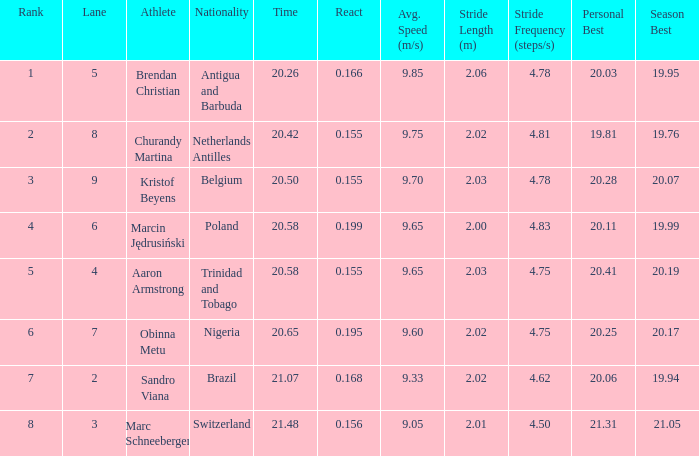How much Time has a Reaction of 0.155, and an Athlete of kristof beyens, and a Rank smaller than 3? 0.0. 